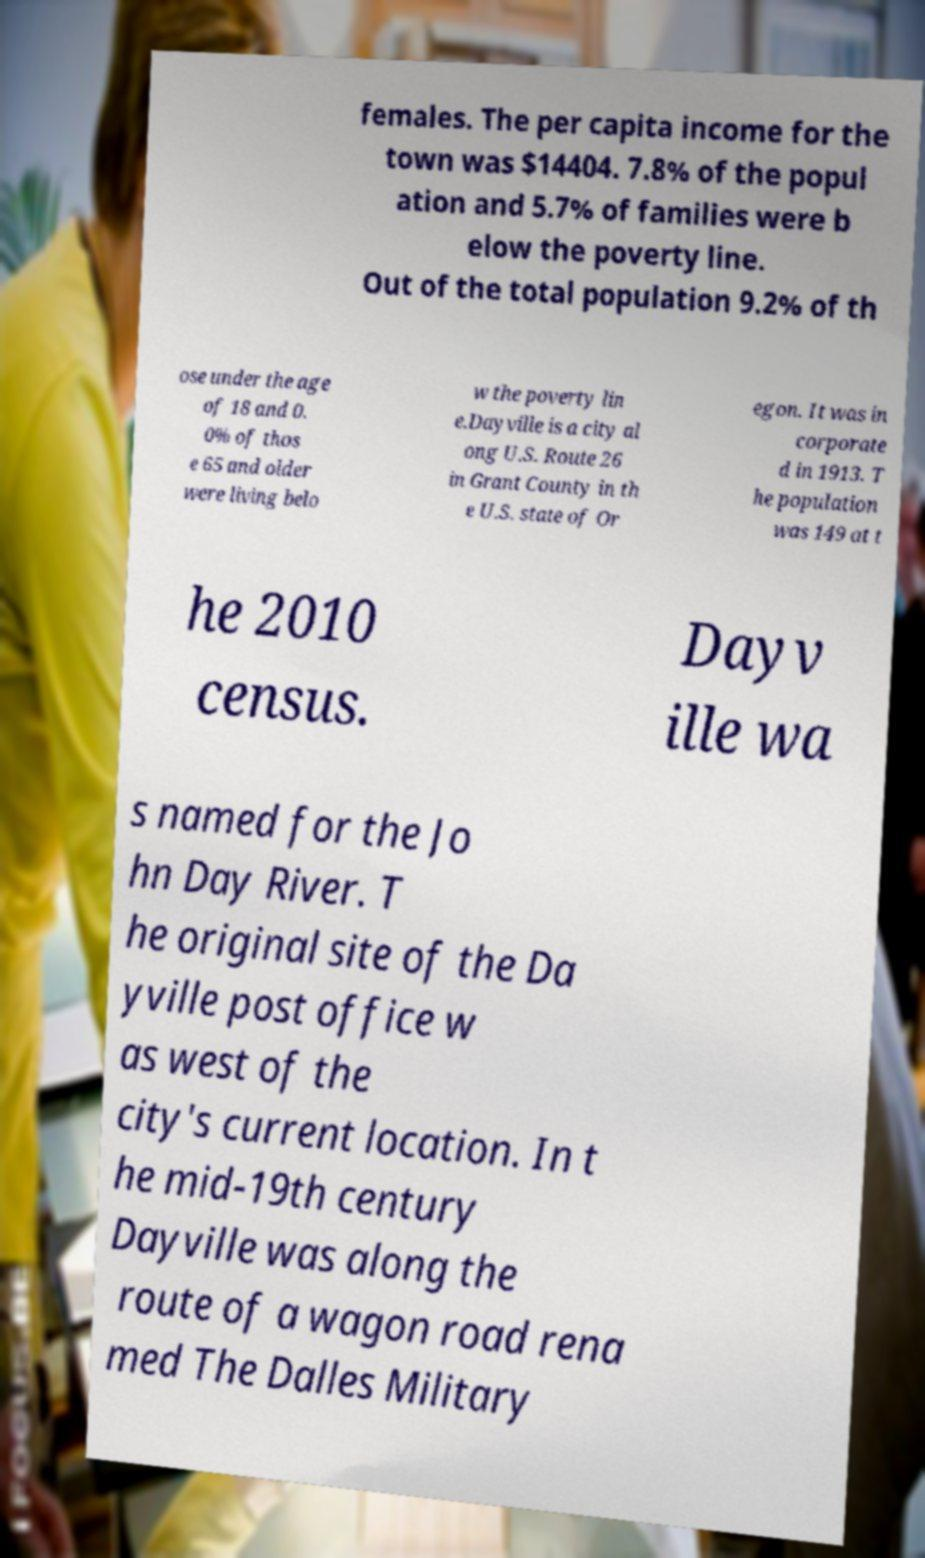For documentation purposes, I need the text within this image transcribed. Could you provide that? females. The per capita income for the town was $14404. 7.8% of the popul ation and 5.7% of families were b elow the poverty line. Out of the total population 9.2% of th ose under the age of 18 and 0. 0% of thos e 65 and older were living belo w the poverty lin e.Dayville is a city al ong U.S. Route 26 in Grant County in th e U.S. state of Or egon. It was in corporate d in 1913. T he population was 149 at t he 2010 census. Dayv ille wa s named for the Jo hn Day River. T he original site of the Da yville post office w as west of the city's current location. In t he mid-19th century Dayville was along the route of a wagon road rena med The Dalles Military 